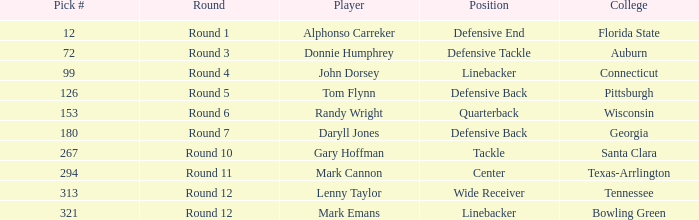Can you give me this table as a dict? {'header': ['Pick #', 'Round', 'Player', 'Position', 'College'], 'rows': [['12', 'Round 1', 'Alphonso Carreker', 'Defensive End', 'Florida State'], ['72', 'Round 3', 'Donnie Humphrey', 'Defensive Tackle', 'Auburn'], ['99', 'Round 4', 'John Dorsey', 'Linebacker', 'Connecticut'], ['126', 'Round 5', 'Tom Flynn', 'Defensive Back', 'Pittsburgh'], ['153', 'Round 6', 'Randy Wright', 'Quarterback', 'Wisconsin'], ['180', 'Round 7', 'Daryll Jones', 'Defensive Back', 'Georgia'], ['267', 'Round 10', 'Gary Hoffman', 'Tackle', 'Santa Clara'], ['294', 'Round 11', 'Mark Cannon', 'Center', 'Texas-Arrlington'], ['313', 'Round 12', 'Lenny Taylor', 'Wide Receiver', 'Tennessee'], ['321', 'Round 12', 'Mark Emans', 'Linebacker', 'Bowling Green']]} What is Mark Cannon's College? Texas-Arrlington. 